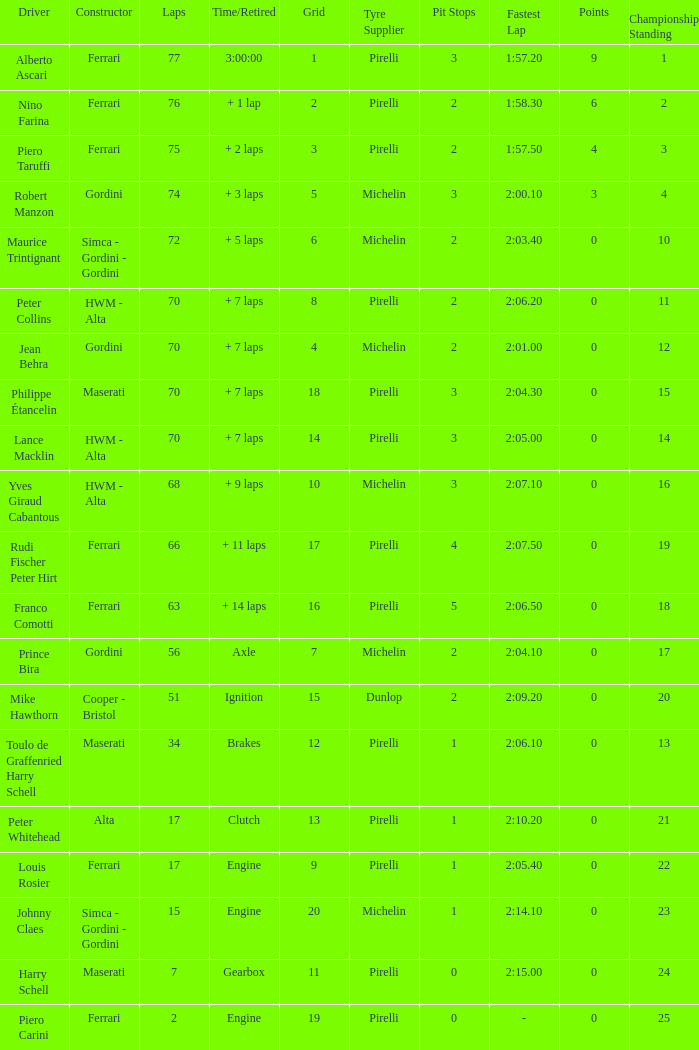Who drove the car with over 66 laps with a grid of 5? Robert Manzon. 